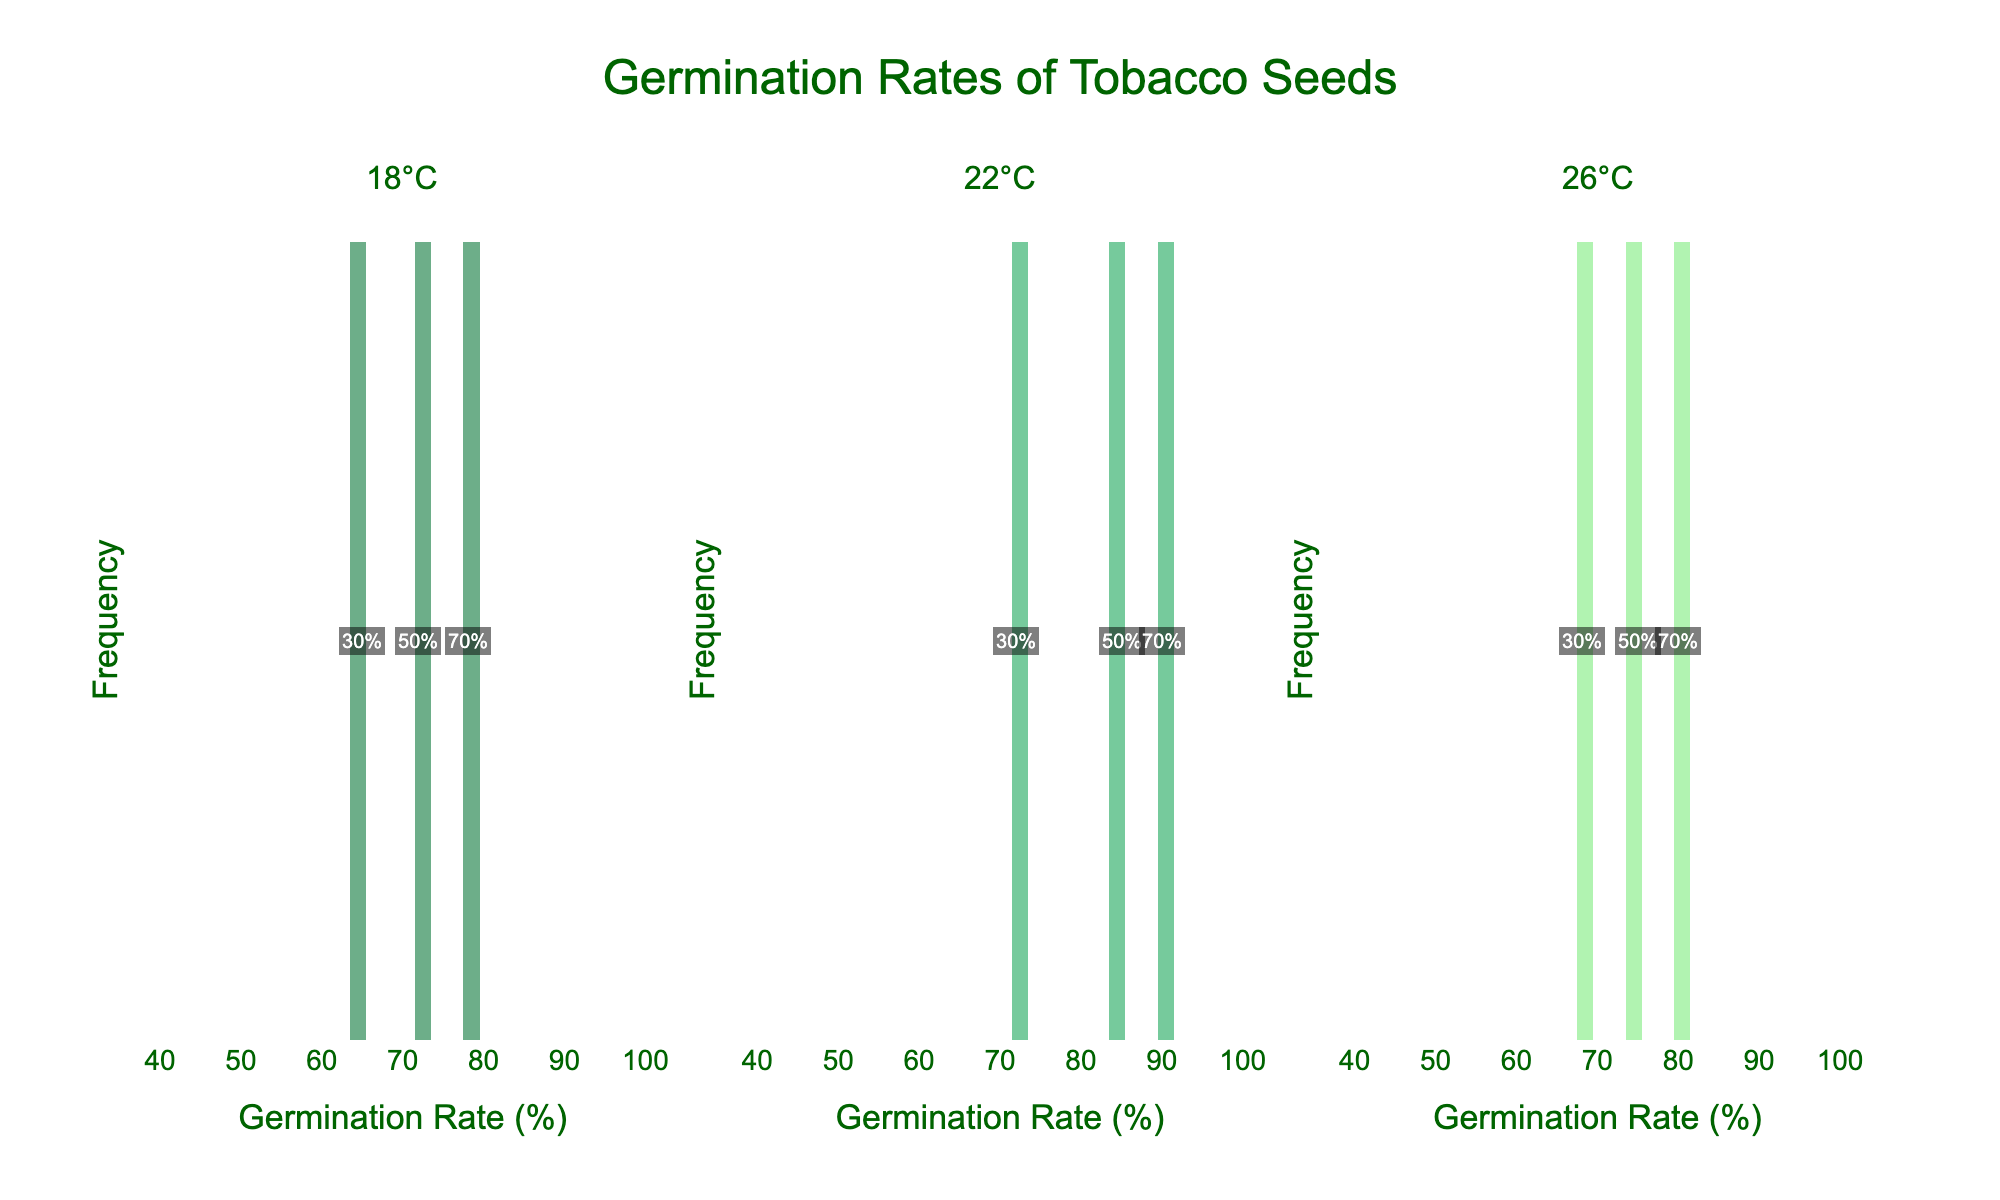How many subplots are in the figure? The figure has title headers for three different temperatures, each representing a distinct subplot, indicating the presence of three subplots.
Answer: 3 What are the temperatures represented in the figure's subplots? Each subplot is titled with a temperature heading, specifically "18°C", "22°C", and "26°C".
Answer: 18°C, 22°C, 26°C Which temperature has the highest germination rate? By examining the plots, the highest germination rate, observed at between 90% and 100%, appears in the subplot for 22°C.
Answer: 22°C What's the range of the x-axis (Germination Rate) in the figure? The x-axis range can be read from the plots, which spans from 40% to 100%.
Answer: 40% to 100% At 26°C, how many data points correspond to a germination rate in the range of 70-80%? In the 26°C subplot, there is one data point annotated at 80% within the specified range of 70-80%.
Answer: 1 Which temperature has the lowest minimum germination rate, and what is it? The subplot for 30°C shows the lowest minimum germination rate observed in the entire plot, which is 50%.
Answer: 30°C, 50% Compare the germination rates at 18°C and 26°C. Which has a higher median rate? To find the median, we sort the germination rates for 18°C (65%, 72%, 78%) and for 26°C (68%, 75%, 80%). The median at 18°C is 72%, and at 26°C, it's 75%. Thus, 26°C has a higher median rate.
Answer: 26°C How does the germination rate distribution at 22°C compare to 18°C? Examining both distributions, 22°C generally shows higher germination rates with a peak around 90%, whereas 18°C has lower rates peaking around 78%.
Answer: 22°C has higher rates At 18°C, what are the humidity values corresponding to germination rates 65%, 72%, and 78%? From the annotations in the 18°C subplot, the humidity levels for these germination rates are 30%, 50%, and 70%, respectively.
Answer: 30%, 50%, 70% Do any temperature conditions show overlapping germination rates? If so, specify. Overlapping germination rates are observed primarily between 18°C (78%) and 26°C (80%), indicating similar values.
Answer: 18°C, 26°C 